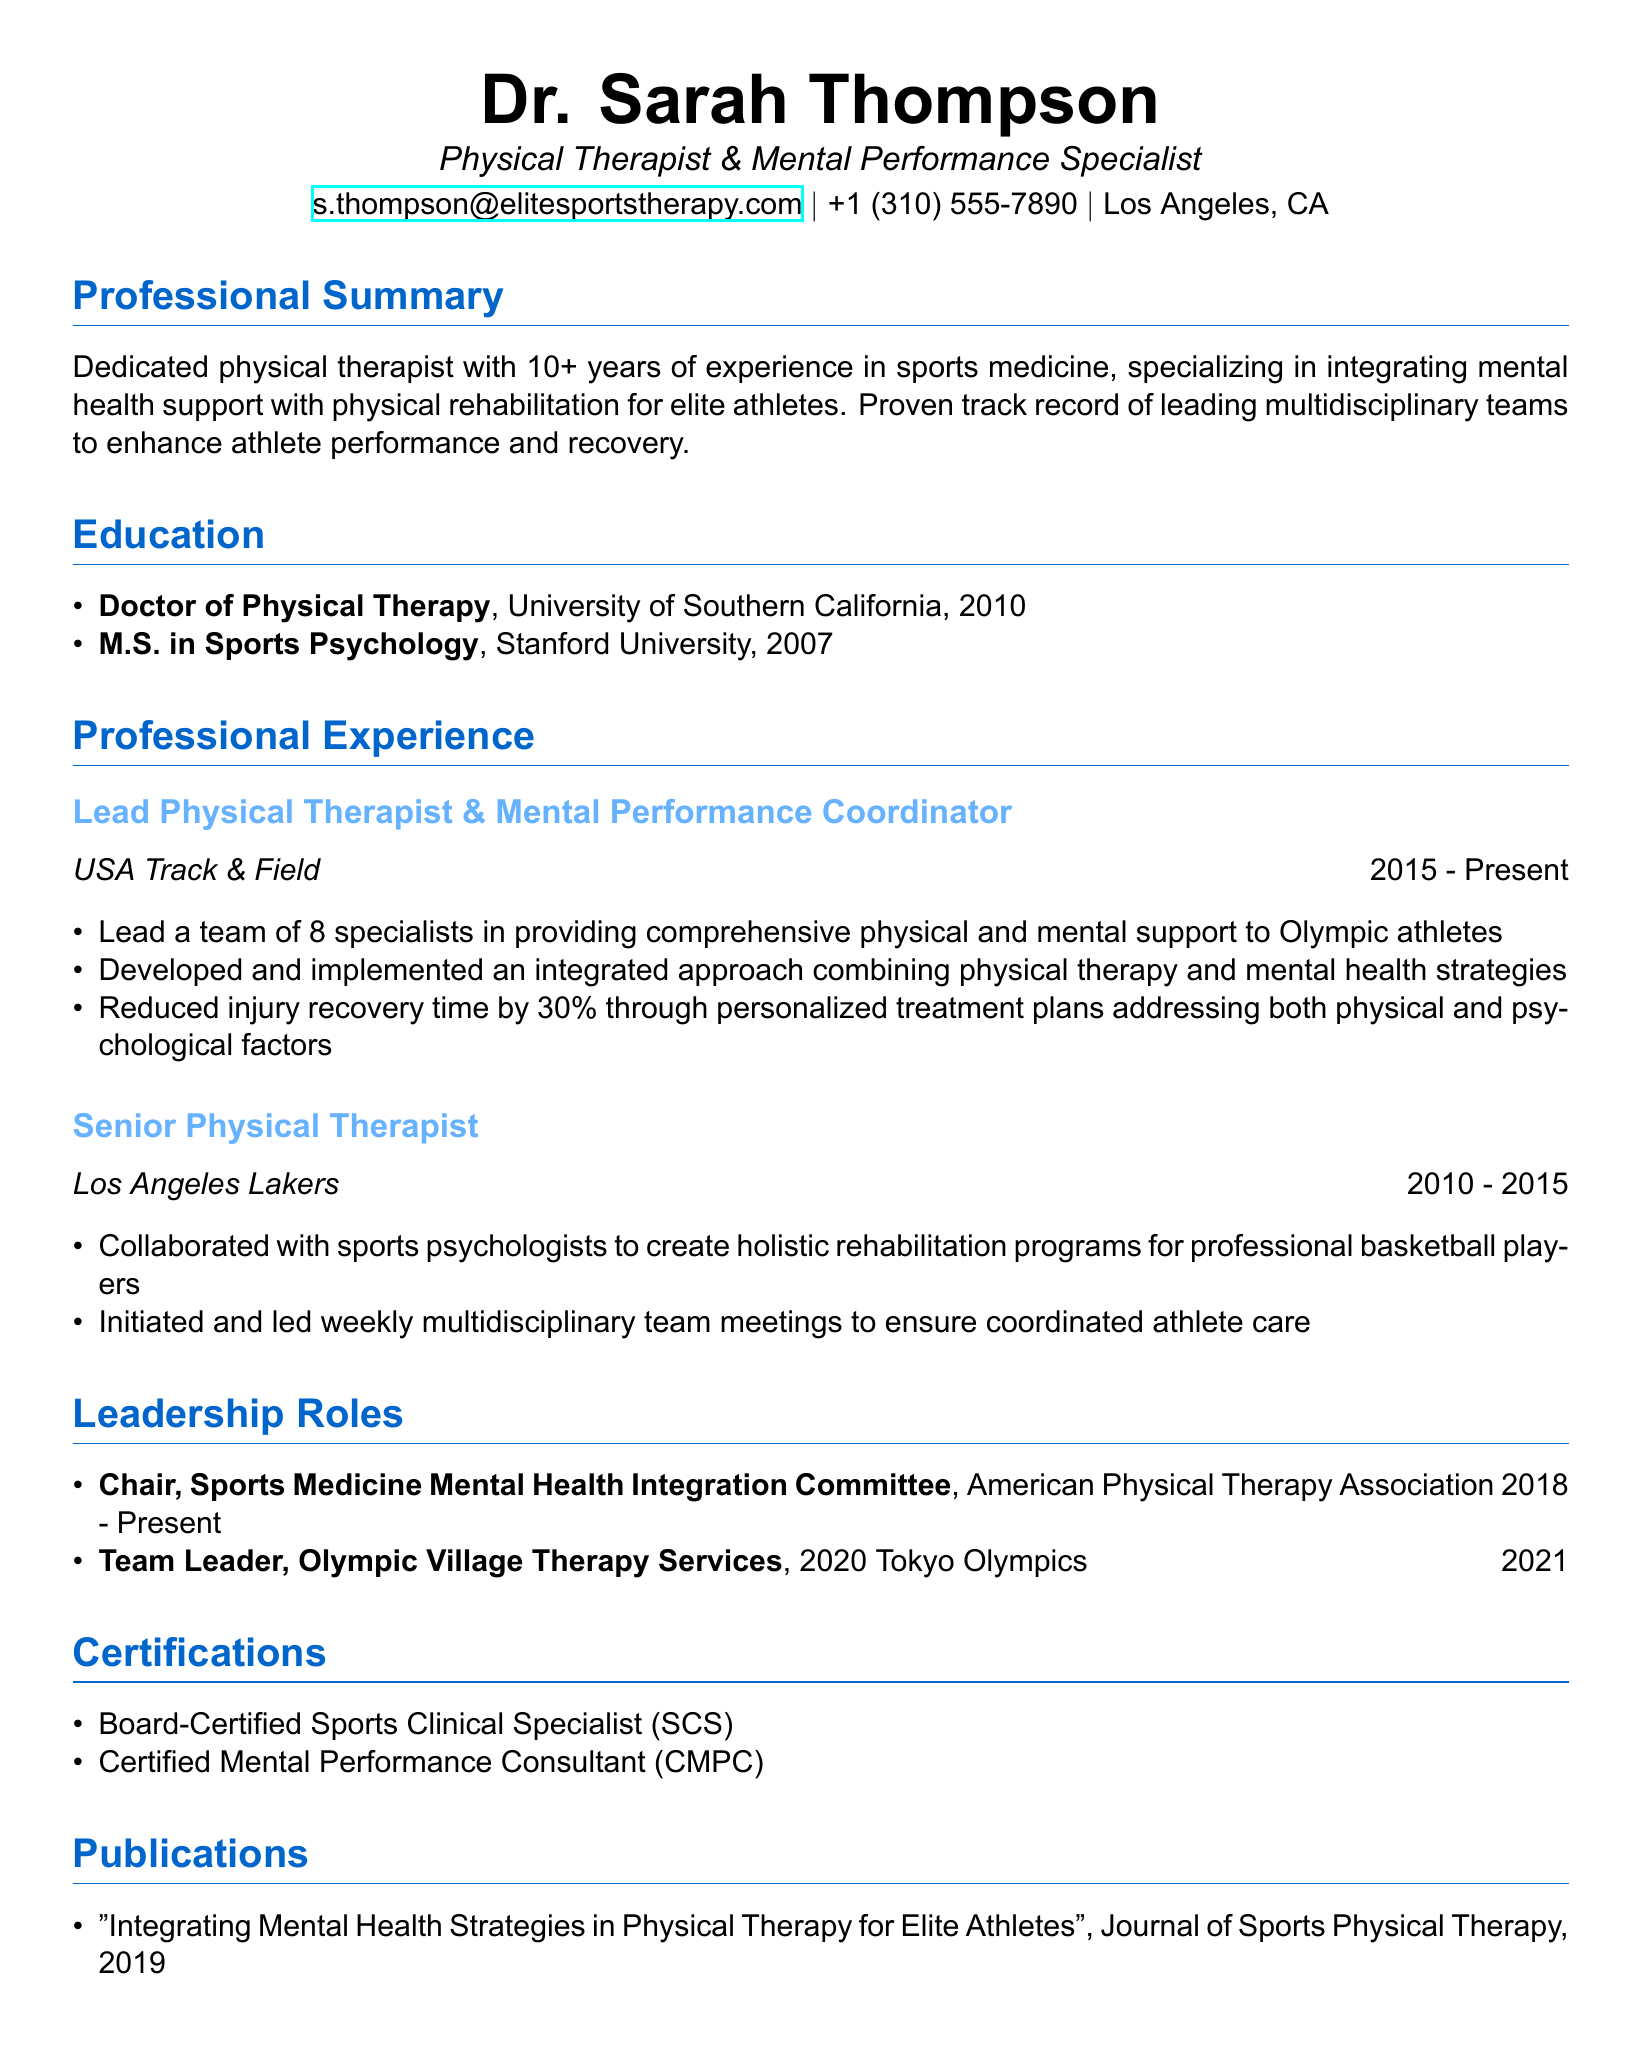What is the name of the individual? The name of the individual is the first piece of information provided in the document.
Answer: Dr. Sarah Thompson What is the highest degree obtained? The highest degree is mentioned under the education section, which lists the Doctor of Physical Therapy as the highest degree.
Answer: Doctor of Physical Therapy Which organization does Sarah currently work for? The current organization is listed in the professional experience section, specifically under her current role.
Answer: USA Track & Field What year did Sarah start working with the Los Angeles Lakers? The start year for her role with the Lakers is provided in the professional experience section, indicating when she began.
Answer: 2010 How many specialists does Sarah lead in her current role? The document specifies the number of specialists under her responsibilities in the current role.
Answer: 8 What is the title of Sarah's publication? The title of the publication is explicitly stated in the publications section of the document.
Answer: Integrating Mental Health Strategies in Physical Therapy for Elite Athletes Which committee does Sarah chair? The document lists the leadership roles and specifies her position on the committee related to mental health integration.
Answer: Sports Medicine Mental Health Integration Committee During which event did Sarah serve as Team Leader for Therapy Services? The event for which she was a Team Leader is indicated in the leadership roles section, specifying the Olympics.
Answer: 2020 Tokyo Olympics What certification qualifies Sarah as a Sports Clinical Specialist? One of the certifications in the document specifies her qualifications as a specialist in sports.
Answer: Board-Certified Sports Clinical Specialist (SCS) 